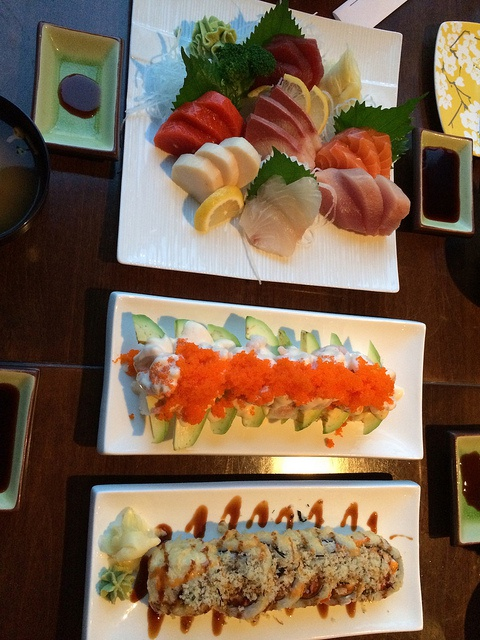Describe the objects in this image and their specific colors. I can see dining table in blue, black, maroon, lightgray, and tan tones, bowl in blue, teal, olive, and black tones, bowl in blue, black, olive, gray, and darkgray tones, carrot in blue, red, and brown tones, and bowl in blue, black, olive, and darkgray tones in this image. 